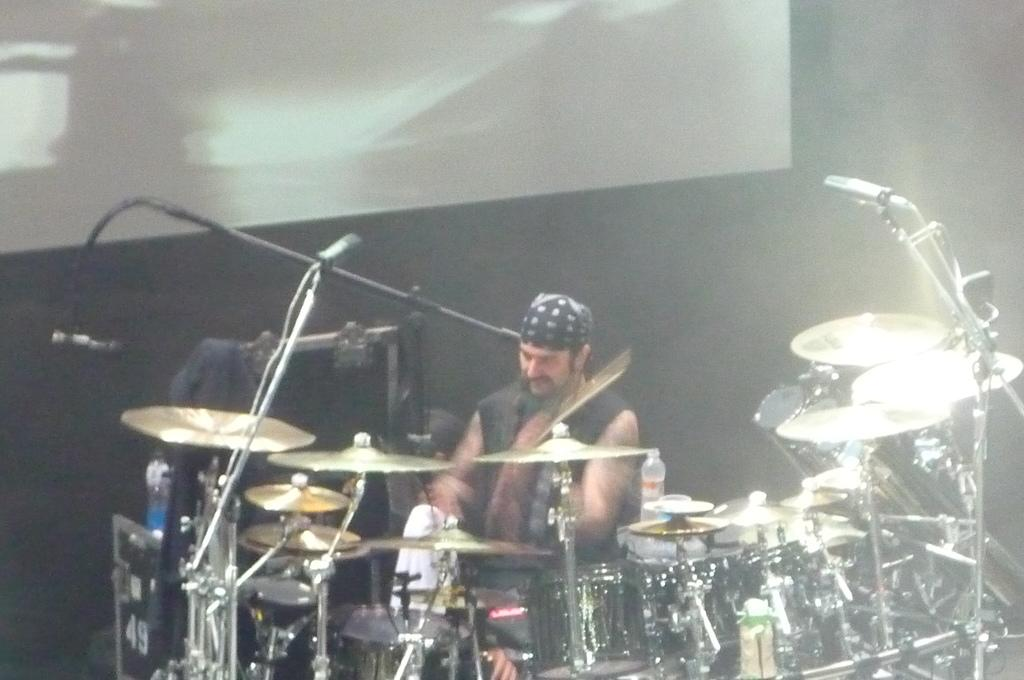How many people are in the image? There are two persons in the image. What are the two persons doing in the image? They are playing musical instruments. Where are the two persons located in the image? They are on a stage. What can be seen in the background of the image? There is a screen in the background of the image. What type of event might the image be capturing? The image may have been taken at a concert. What type of joke is being told by the person on the left in the image? There is no indication of a joke being told in the image; the two persons are playing musical instruments. How many steps are visible on the stage in the image? There is no mention of steps on the stage in the image; only the two persons and a screen are visible. 